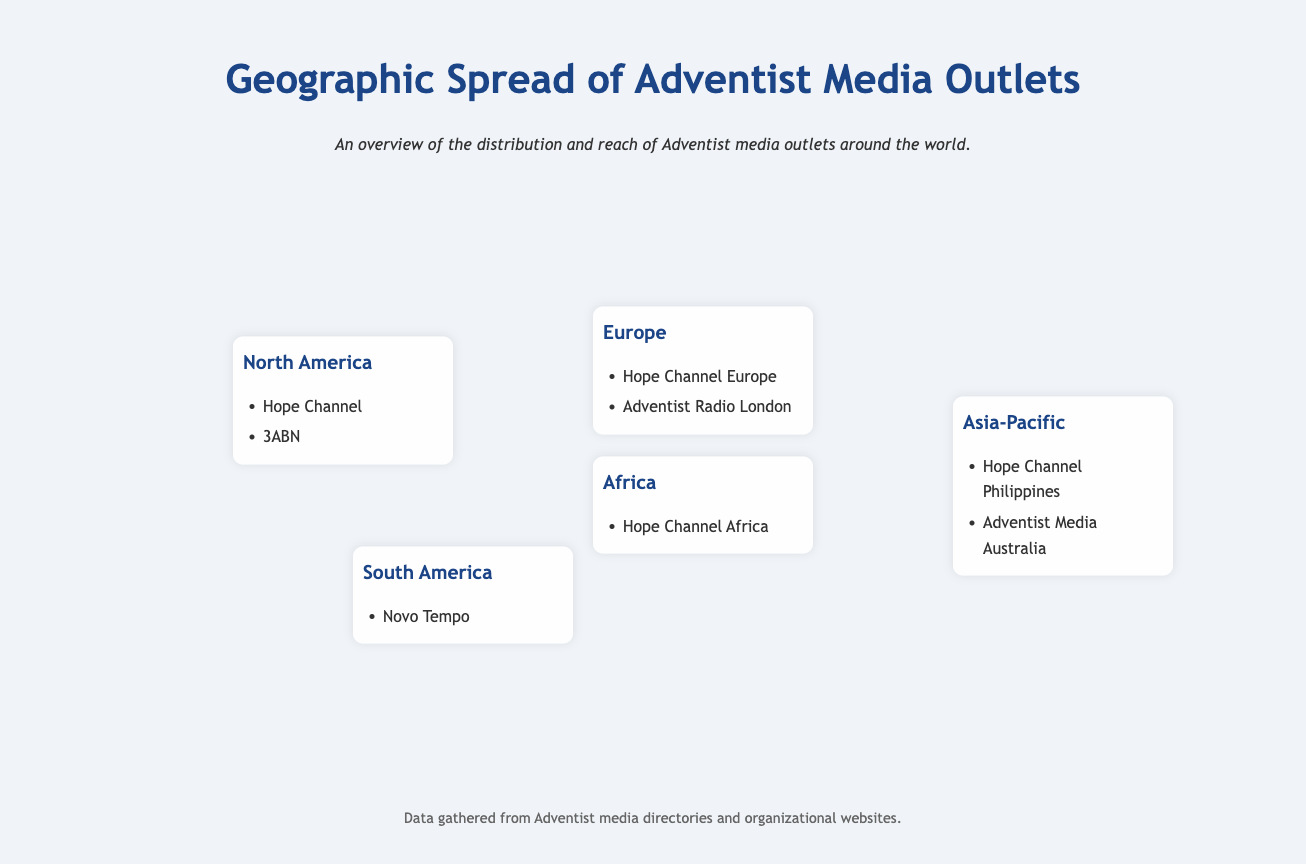What are the two media outlets in North America? The document lists Hope Channel and 3ABN as the media outlets in North America.
Answer: Hope Channel, 3ABN Which media outlet is mentioned for South America? The document indicates that Novo Tempo is the media outlet in South America.
Answer: Novo Tempo How many media outlets are listed for Europe? The document lists two media outlets: Hope Channel Europe and Adventist Radio London, which totals to two.
Answer: 2 What is the name of the media outlet in Africa? The document specifies Hope Channel Africa as the media outlet in Africa.
Answer: Hope Channel Africa Which region has the most listed media outlets? North America has the most listed media outlets with two mentioned.
Answer: North America How many regions are mentioned in the document? The document describes five regions: North America, South America, Europe, Africa, and Asia-Pacific.
Answer: 5 Which media outlet is found in Asia-Pacific? The document lists Hope Channel Philippines and Adventist Media Australia as media outlets in Asia-Pacific.
Answer: Hope Channel Philippines, Adventist Media Australia What is the color scheme for the header of the infographic? The header color scheme for the infographic is a shade of blue (#1c4587).
Answer: #1c4587 What type of data is depicted in this infographic? The data depicted in the infographic shows the geographic spread of Adventist media outlets around the world.
Answer: Geographic spread of Adventist media outlets 